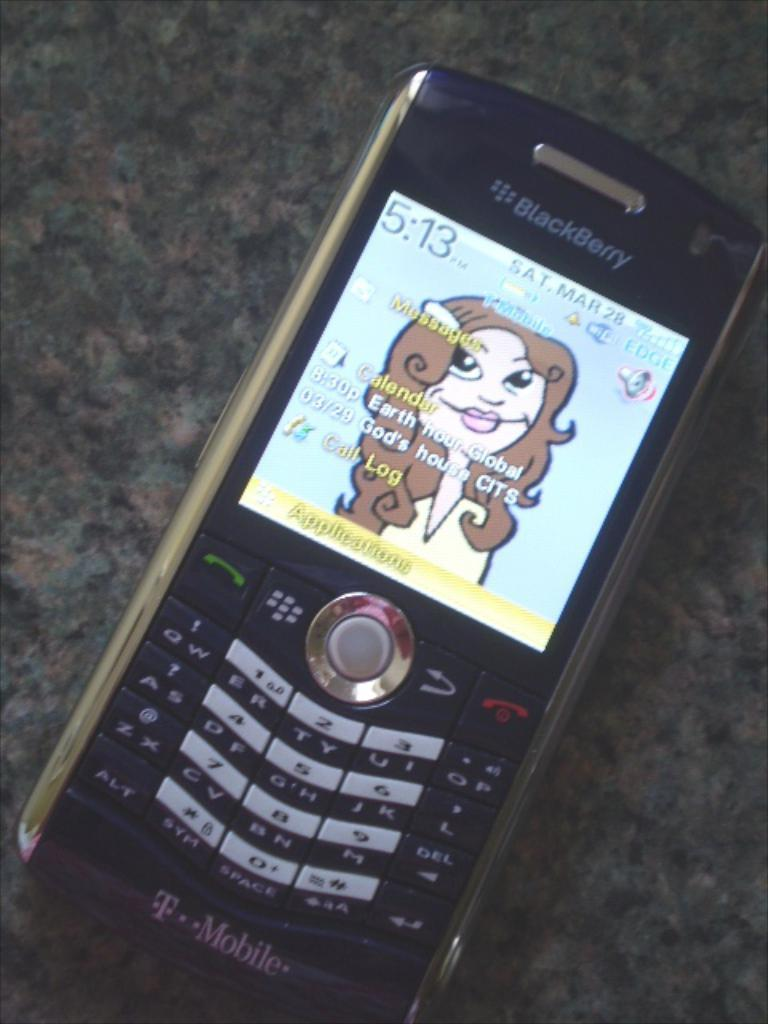Provide a one-sentence caption for the provided image. a phone that has a call log on it. 